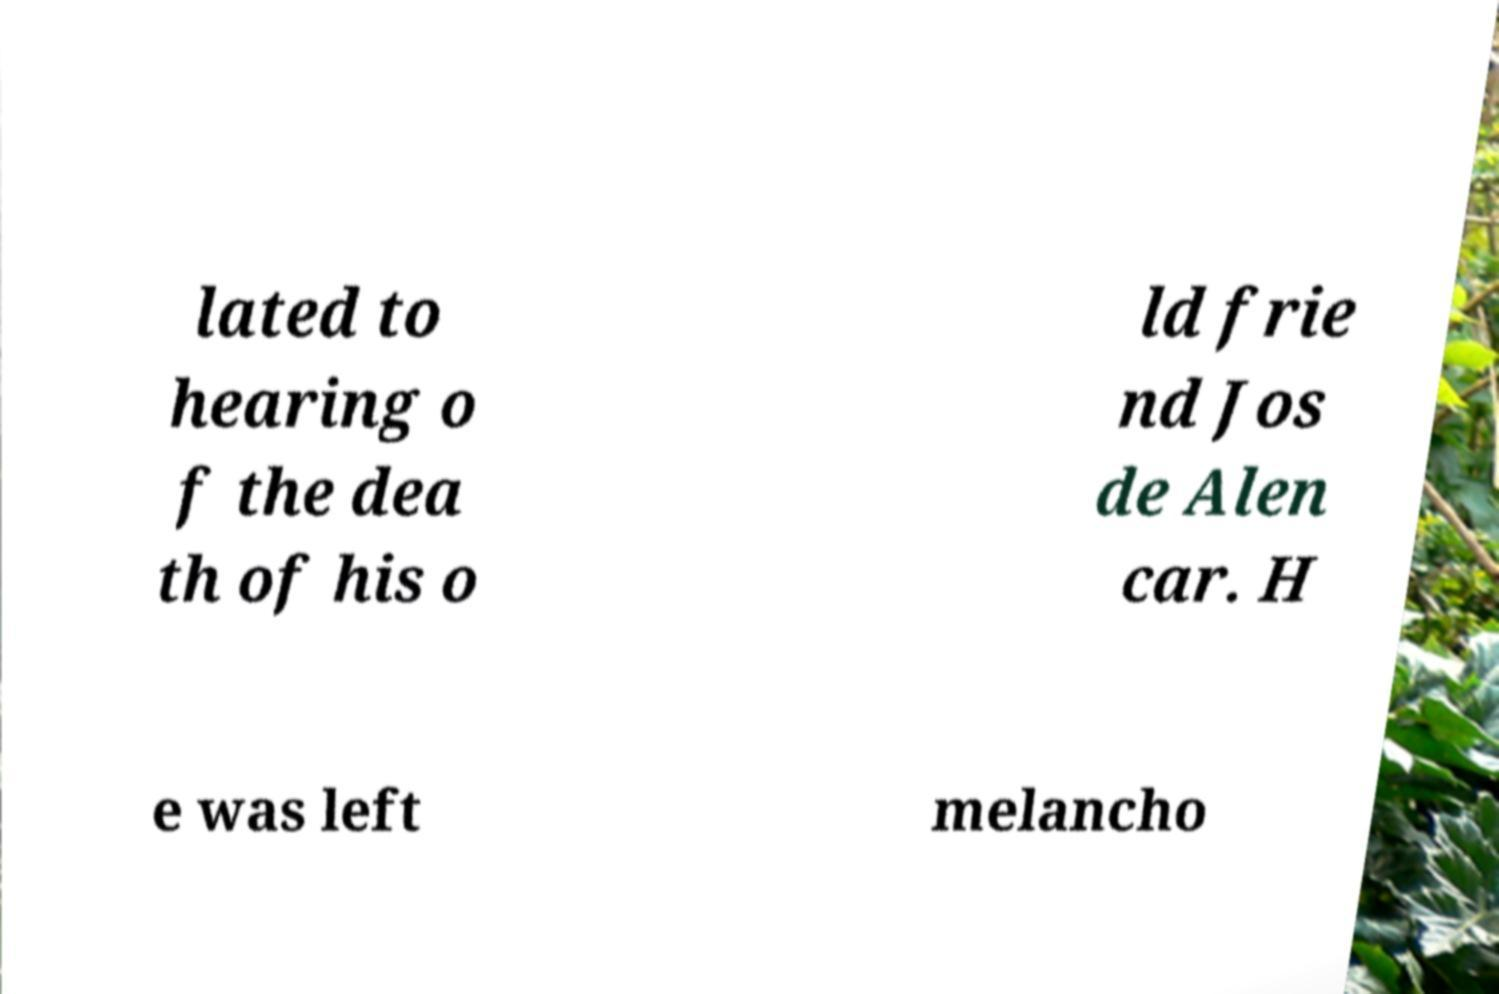There's text embedded in this image that I need extracted. Can you transcribe it verbatim? lated to hearing o f the dea th of his o ld frie nd Jos de Alen car. H e was left melancho 